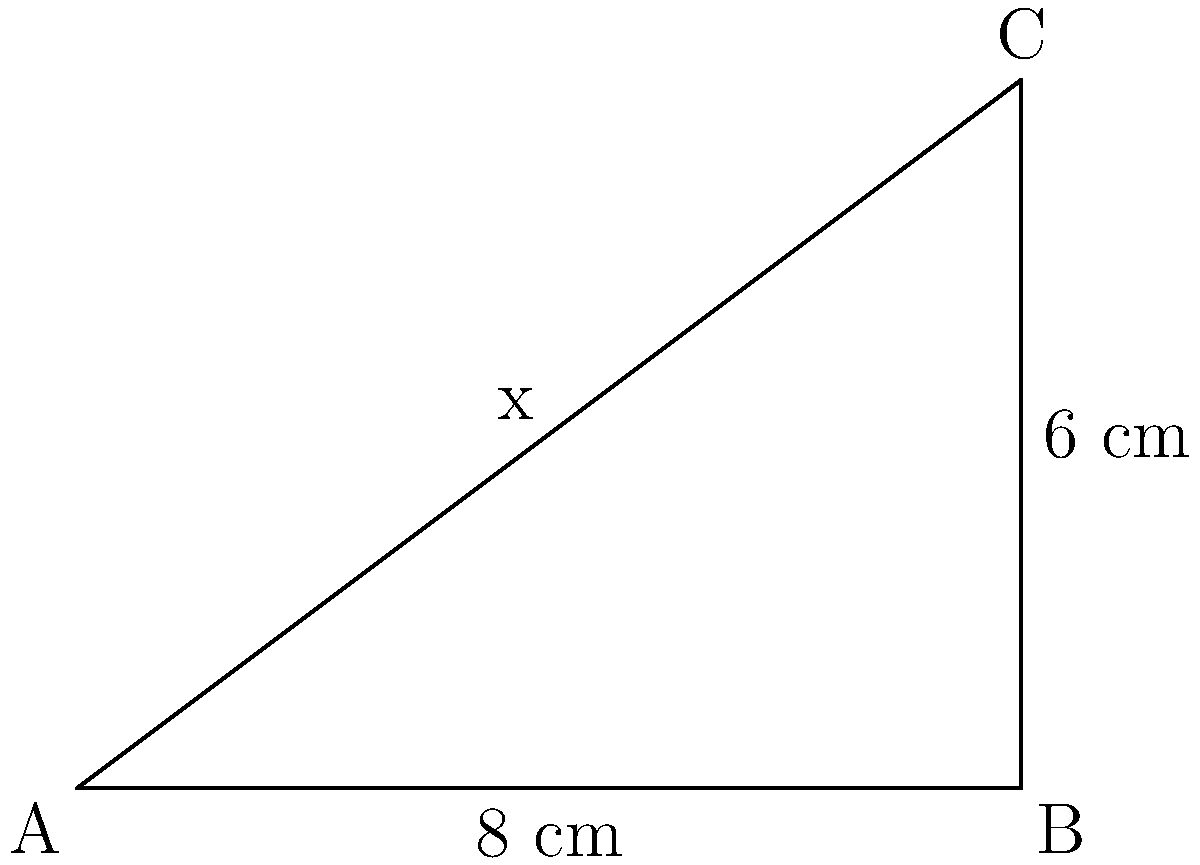Your punk rock band's guitarist needs a new string for their Flying V guitar. The distance from the bridge to the nut is 8 cm, and the string needs to be elevated 6 cm above the fretboard at its highest point. How long should the new guitar string be to fit perfectly? Let's approach this step-by-step using the Pythagorean theorem:

1) We can view the guitar string as the hypotenuse of a right-angled triangle.

2) We know two sides of this triangle:
   - The base (distance from bridge to nut) is 8 cm
   - The height (elevation of string) is 6 cm

3) Let's call the length of the string $x$.

4) Using the Pythagorean theorem:

   $$x^2 = 8^2 + 6^2$$

5) Simplify:
   $$x^2 = 64 + 36 = 100$$

6) Take the square root of both sides:
   $$x = \sqrt{100} = 10$$

Therefore, the length of the guitar string should be 10 cm.
Answer: 10 cm 